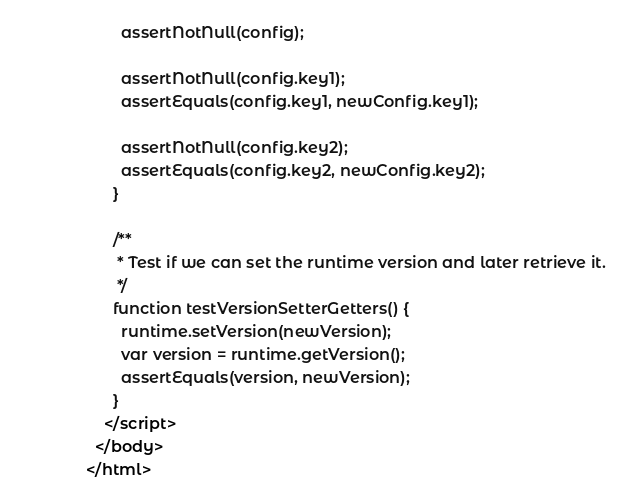Convert code to text. <code><loc_0><loc_0><loc_500><loc_500><_HTML_>        assertNotNull(config);

        assertNotNull(config.key1);
        assertEquals(config.key1, newConfig.key1);

        assertNotNull(config.key2);
        assertEquals(config.key2, newConfig.key2);
      }

      /**
       * Test if we can set the runtime version and later retrieve it.
       */
      function testVersionSetterGetters() {
        runtime.setVersion(newVersion);
        var version = runtime.getVersion();
        assertEquals(version, newVersion);
      }
    </script>
  </body>
</html>
</code> 